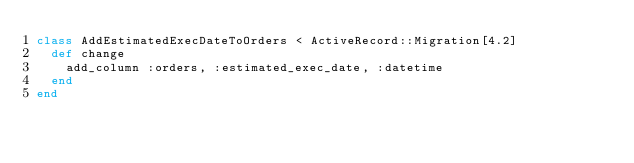Convert code to text. <code><loc_0><loc_0><loc_500><loc_500><_Ruby_>class AddEstimatedExecDateToOrders < ActiveRecord::Migration[4.2]
  def change
    add_column :orders, :estimated_exec_date, :datetime
  end
end
</code> 